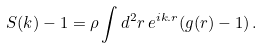Convert formula to latex. <formula><loc_0><loc_0><loc_500><loc_500>S ( k ) - 1 = \rho \int d ^ { 2 } r \, e ^ { i { k } . { r } } ( g ( r ) - 1 ) \, .</formula> 